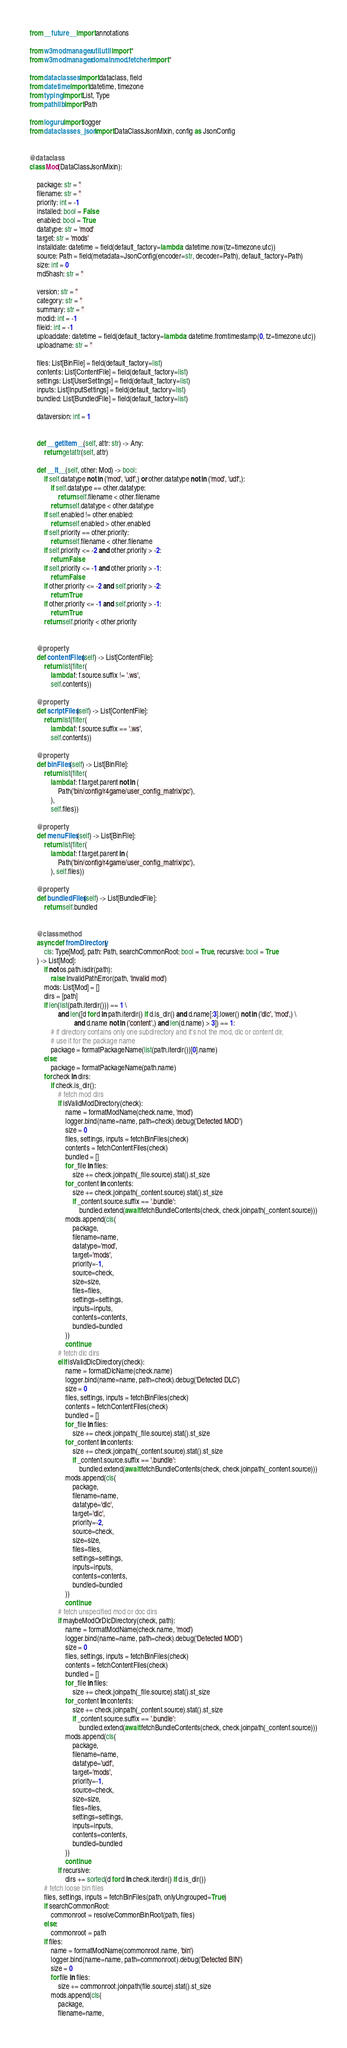Convert code to text. <code><loc_0><loc_0><loc_500><loc_500><_Python_>from __future__ import annotations

from w3modmanager.util.util import *
from w3modmanager.domain.mod.fetcher import *

from dataclasses import dataclass, field
from datetime import datetime, timezone
from typing import List, Type
from pathlib import Path

from loguru import logger
from dataclasses_json import DataClassJsonMixin, config as JsonConfig


@dataclass
class Mod(DataClassJsonMixin):

    package: str = ''
    filename: str = ''
    priority: int = -1
    installed: bool = False
    enabled: bool = True
    datatype: str = 'mod'
    target: str = 'mods'
    installdate: datetime = field(default_factory=lambda: datetime.now(tz=timezone.utc))
    source: Path = field(metadata=JsonConfig(encoder=str, decoder=Path), default_factory=Path)
    size: int = 0
    md5hash: str = ''

    version: str = ''
    category: str = ''
    summary: str = ''
    modid: int = -1
    fileid: int = -1
    uploaddate: datetime = field(default_factory=lambda: datetime.fromtimestamp(0, tz=timezone.utc))
    uploadname: str = ''

    files: List[BinFile] = field(default_factory=list)
    contents: List[ContentFile] = field(default_factory=list)
    settings: List[UserSettings] = field(default_factory=list)
    inputs: List[InputSettings] = field(default_factory=list)
    bundled: List[BundledFile] = field(default_factory=list)

    dataversion: int = 1


    def __getitem__(self, attr: str) -> Any:
        return getattr(self, attr)

    def __lt__(self, other: Mod) -> bool:
        if self.datatype not in ('mod', 'udf',) or other.datatype not in ('mod', 'udf',):
            if self.datatype == other.datatype:
                return self.filename < other.filename
            return self.datatype < other.datatype
        if self.enabled != other.enabled:
            return self.enabled > other.enabled
        if self.priority == other.priority:
            return self.filename < other.filename
        if self.priority <= -2 and other.priority > -2:
            return False
        if self.priority <= -1 and other.priority > -1:
            return False
        if other.priority <= -2 and self.priority > -2:
            return True
        if other.priority <= -1 and self.priority > -1:
            return True
        return self.priority < other.priority


    @property
    def contentFiles(self) -> List[ContentFile]:
        return list(filter(
            lambda f: f.source.suffix != '.ws',
            self.contents))

    @property
    def scriptFiles(self) -> List[ContentFile]:
        return list(filter(
            lambda f: f.source.suffix == '.ws',
            self.contents))

    @property
    def binFiles(self) -> List[BinFile]:
        return list(filter(
            lambda f: f.target.parent not in (
                Path('bin/config/r4game/user_config_matrix/pc'),
            ),
            self.files))

    @property
    def menuFiles(self) -> List[BinFile]:
        return list(filter(
            lambda f: f.target.parent in (
                Path('bin/config/r4game/user_config_matrix/pc'),
            ), self.files))

    @property
    def bundledFiles(self) -> List[BundledFile]:
        return self.bundled


    @classmethod
    async def fromDirectory(
        cls: Type[Mod], path: Path, searchCommonRoot: bool = True, recursive: bool = True
    ) -> List[Mod]:
        if not os.path.isdir(path):
            raise InvalidPathError(path, 'Invalid mod')
        mods: List[Mod] = []
        dirs = [path]
        if len(list(path.iterdir())) == 1 \
                and len([d for d in path.iterdir() if d.is_dir() and d.name[:3].lower() not in ('dlc', 'mod',) \
                         and d.name not in ('content',) and len(d.name) > 3]) == 1:
            # if directory contains only one subdirectory and it's not the mod, dlc or content dir,
            # use it for the package name
            package = formatPackageName(list(path.iterdir())[0].name)
        else:
            package = formatPackageName(path.name)
        for check in dirs:
            if check.is_dir():
                # fetch mod dirs
                if isValidModDirectory(check):
                    name = formatModName(check.name, 'mod')
                    logger.bind(name=name, path=check).debug('Detected MOD')
                    size = 0
                    files, settings, inputs = fetchBinFiles(check)
                    contents = fetchContentFiles(check)
                    bundled = []
                    for _file in files:
                        size += check.joinpath(_file.source).stat().st_size
                    for _content in contents:
                        size += check.joinpath(_content.source).stat().st_size
                        if _content.source.suffix == '.bundle':
                            bundled.extend(await fetchBundleContents(check, check.joinpath(_content.source)))
                    mods.append(cls(
                        package,
                        filename=name,
                        datatype='mod',
                        target='mods',
                        priority=-1,
                        source=check,
                        size=size,
                        files=files,
                        settings=settings,
                        inputs=inputs,
                        contents=contents,
                        bundled=bundled
                    ))
                    continue
                # fetch dlc dirs
                elif isValidDlcDirectory(check):
                    name = formatDlcName(check.name)
                    logger.bind(name=name, path=check).debug('Detected DLC')
                    size = 0
                    files, settings, inputs = fetchBinFiles(check)
                    contents = fetchContentFiles(check)
                    bundled = []
                    for _file in files:
                        size += check.joinpath(_file.source).stat().st_size
                    for _content in contents:
                        size += check.joinpath(_content.source).stat().st_size
                        if _content.source.suffix == '.bundle':
                            bundled.extend(await fetchBundleContents(check, check.joinpath(_content.source)))
                    mods.append(cls(
                        package,
                        filename=name,
                        datatype='dlc',
                        target='dlc',
                        priority=-2,
                        source=check,
                        size=size,
                        files=files,
                        settings=settings,
                        inputs=inputs,
                        contents=contents,
                        bundled=bundled
                    ))
                    continue
                # fetch unspecified mod or doc dirs
                if maybeModOrDlcDirectory(check, path):
                    name = formatModName(check.name, 'mod')
                    logger.bind(name=name, path=check).debug('Detected MOD')
                    size = 0
                    files, settings, inputs = fetchBinFiles(check)
                    contents = fetchContentFiles(check)
                    bundled = []
                    for _file in files:
                        size += check.joinpath(_file.source).stat().st_size
                    for _content in contents:
                        size += check.joinpath(_content.source).stat().st_size
                        if _content.source.suffix == '.bundle':
                            bundled.extend(await fetchBundleContents(check, check.joinpath(_content.source)))
                    mods.append(cls(
                        package,
                        filename=name,
                        datatype='udf',
                        target='mods',
                        priority=-1,
                        source=check,
                        size=size,
                        files=files,
                        settings=settings,
                        inputs=inputs,
                        contents=contents,
                        bundled=bundled
                    ))
                    continue
                if recursive:
                    dirs += sorted(d for d in check.iterdir() if d.is_dir())
        # fetch loose bin files
        files, settings, inputs = fetchBinFiles(path, onlyUngrouped=True)
        if searchCommonRoot:
            commonroot = resolveCommonBinRoot(path, files)
        else:
            commonroot = path
        if files:
            name = formatModName(commonroot.name, 'bin')
            logger.bind(name=name, path=commonroot).debug('Detected BIN')
            size = 0
            for file in files:
                size += commonroot.joinpath(file.source).stat().st_size
            mods.append(cls(
                package,
                filename=name,</code> 